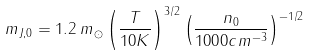<formula> <loc_0><loc_0><loc_500><loc_500>m _ { J , 0 } = 1 . 2 \, m _ { \odot } \left ( \frac { T } { 1 0 K } \right ) ^ { 3 / 2 } \left ( \frac { n _ { 0 } } { 1 0 0 0 c m ^ { - 3 } } \right ) ^ { - 1 / 2 }</formula> 